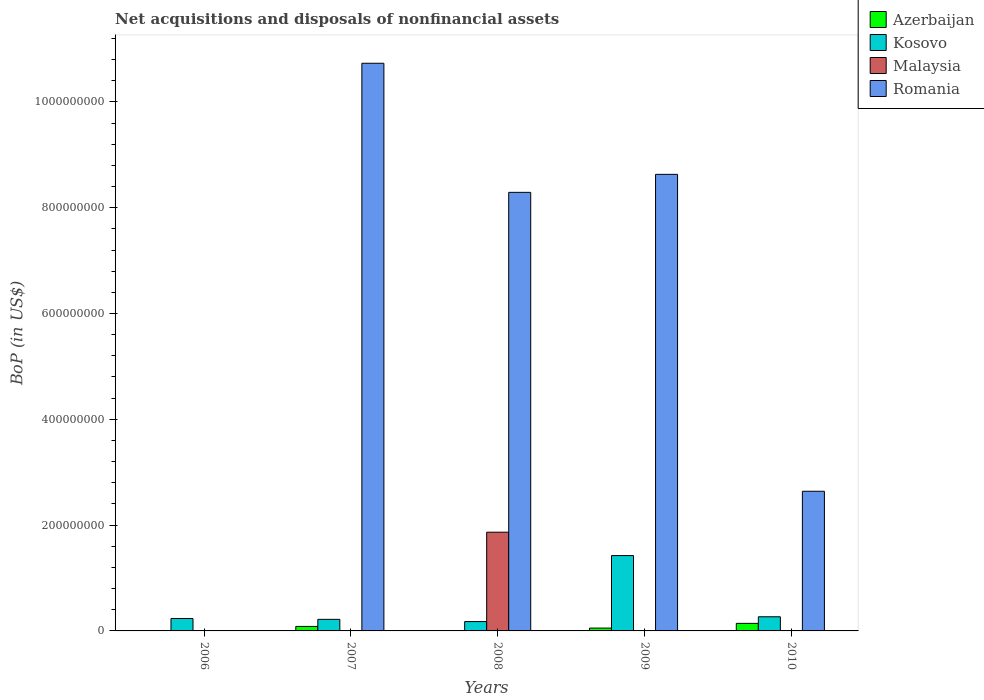How many groups of bars are there?
Your response must be concise. 5. Are the number of bars per tick equal to the number of legend labels?
Your answer should be compact. No. Are the number of bars on each tick of the X-axis equal?
Give a very brief answer. No. How many bars are there on the 2nd tick from the left?
Your response must be concise. 3. What is the Balance of Payments in Kosovo in 2006?
Ensure brevity in your answer.  2.35e+07. Across all years, what is the maximum Balance of Payments in Kosovo?
Provide a succinct answer. 1.42e+08. Across all years, what is the minimum Balance of Payments in Azerbaijan?
Ensure brevity in your answer.  0. What is the total Balance of Payments in Malaysia in the graph?
Offer a very short reply. 1.87e+08. What is the difference between the Balance of Payments in Azerbaijan in 2006 and that in 2009?
Provide a succinct answer. -5.06e+06. What is the difference between the Balance of Payments in Azerbaijan in 2008 and the Balance of Payments in Romania in 2009?
Your answer should be very brief. -8.63e+08. What is the average Balance of Payments in Romania per year?
Offer a very short reply. 6.06e+08. In the year 2006, what is the difference between the Balance of Payments in Kosovo and Balance of Payments in Azerbaijan?
Your response must be concise. 2.32e+07. What is the ratio of the Balance of Payments in Azerbaijan in 2007 to that in 2010?
Make the answer very short. 0.59. Is the Balance of Payments in Kosovo in 2007 less than that in 2010?
Your answer should be very brief. Yes. What is the difference between the highest and the second highest Balance of Payments in Kosovo?
Your answer should be compact. 1.16e+08. What is the difference between the highest and the lowest Balance of Payments in Malaysia?
Give a very brief answer. 1.87e+08. In how many years, is the Balance of Payments in Romania greater than the average Balance of Payments in Romania taken over all years?
Provide a succinct answer. 3. Is it the case that in every year, the sum of the Balance of Payments in Kosovo and Balance of Payments in Malaysia is greater than the Balance of Payments in Romania?
Your answer should be very brief. No. How many bars are there?
Your answer should be compact. 14. How many years are there in the graph?
Provide a short and direct response. 5. What is the difference between two consecutive major ticks on the Y-axis?
Offer a terse response. 2.00e+08. Does the graph contain any zero values?
Keep it short and to the point. Yes. Where does the legend appear in the graph?
Provide a succinct answer. Top right. How many legend labels are there?
Make the answer very short. 4. How are the legend labels stacked?
Give a very brief answer. Vertical. What is the title of the graph?
Make the answer very short. Net acquisitions and disposals of nonfinancial assets. What is the label or title of the Y-axis?
Offer a terse response. BoP (in US$). What is the BoP (in US$) in Azerbaijan in 2006?
Ensure brevity in your answer.  2.85e+05. What is the BoP (in US$) in Kosovo in 2006?
Provide a succinct answer. 2.35e+07. What is the BoP (in US$) in Romania in 2006?
Your response must be concise. 0. What is the BoP (in US$) in Azerbaijan in 2007?
Provide a short and direct response. 8.49e+06. What is the BoP (in US$) of Kosovo in 2007?
Offer a terse response. 2.19e+07. What is the BoP (in US$) of Malaysia in 2007?
Your answer should be very brief. 0. What is the BoP (in US$) of Romania in 2007?
Your response must be concise. 1.07e+09. What is the BoP (in US$) of Azerbaijan in 2008?
Ensure brevity in your answer.  0. What is the BoP (in US$) of Kosovo in 2008?
Your answer should be compact. 1.77e+07. What is the BoP (in US$) in Malaysia in 2008?
Keep it short and to the point. 1.87e+08. What is the BoP (in US$) of Romania in 2008?
Provide a short and direct response. 8.29e+08. What is the BoP (in US$) of Azerbaijan in 2009?
Offer a very short reply. 5.35e+06. What is the BoP (in US$) in Kosovo in 2009?
Provide a succinct answer. 1.42e+08. What is the BoP (in US$) in Malaysia in 2009?
Your response must be concise. 0. What is the BoP (in US$) in Romania in 2009?
Make the answer very short. 8.63e+08. What is the BoP (in US$) of Azerbaijan in 2010?
Give a very brief answer. 1.43e+07. What is the BoP (in US$) in Kosovo in 2010?
Give a very brief answer. 2.67e+07. What is the BoP (in US$) of Malaysia in 2010?
Provide a succinct answer. 0. What is the BoP (in US$) in Romania in 2010?
Offer a very short reply. 2.64e+08. Across all years, what is the maximum BoP (in US$) in Azerbaijan?
Your response must be concise. 1.43e+07. Across all years, what is the maximum BoP (in US$) of Kosovo?
Ensure brevity in your answer.  1.42e+08. Across all years, what is the maximum BoP (in US$) in Malaysia?
Your answer should be compact. 1.87e+08. Across all years, what is the maximum BoP (in US$) in Romania?
Make the answer very short. 1.07e+09. Across all years, what is the minimum BoP (in US$) in Azerbaijan?
Provide a short and direct response. 0. Across all years, what is the minimum BoP (in US$) of Kosovo?
Give a very brief answer. 1.77e+07. Across all years, what is the minimum BoP (in US$) in Malaysia?
Make the answer very short. 0. Across all years, what is the minimum BoP (in US$) of Romania?
Ensure brevity in your answer.  0. What is the total BoP (in US$) of Azerbaijan in the graph?
Your answer should be compact. 2.84e+07. What is the total BoP (in US$) of Kosovo in the graph?
Provide a short and direct response. 2.32e+08. What is the total BoP (in US$) of Malaysia in the graph?
Your answer should be compact. 1.87e+08. What is the total BoP (in US$) of Romania in the graph?
Make the answer very short. 3.03e+09. What is the difference between the BoP (in US$) in Azerbaijan in 2006 and that in 2007?
Provide a succinct answer. -8.21e+06. What is the difference between the BoP (in US$) in Kosovo in 2006 and that in 2007?
Give a very brief answer. 1.60e+06. What is the difference between the BoP (in US$) in Kosovo in 2006 and that in 2008?
Your answer should be compact. 5.78e+06. What is the difference between the BoP (in US$) of Azerbaijan in 2006 and that in 2009?
Provide a succinct answer. -5.06e+06. What is the difference between the BoP (in US$) in Kosovo in 2006 and that in 2009?
Make the answer very short. -1.19e+08. What is the difference between the BoP (in US$) of Azerbaijan in 2006 and that in 2010?
Offer a very short reply. -1.40e+07. What is the difference between the BoP (in US$) of Kosovo in 2006 and that in 2010?
Your answer should be compact. -3.27e+06. What is the difference between the BoP (in US$) in Kosovo in 2007 and that in 2008?
Give a very brief answer. 4.18e+06. What is the difference between the BoP (in US$) in Romania in 2007 and that in 2008?
Keep it short and to the point. 2.44e+08. What is the difference between the BoP (in US$) in Azerbaijan in 2007 and that in 2009?
Your answer should be very brief. 3.14e+06. What is the difference between the BoP (in US$) of Kosovo in 2007 and that in 2009?
Your response must be concise. -1.21e+08. What is the difference between the BoP (in US$) in Romania in 2007 and that in 2009?
Give a very brief answer. 2.10e+08. What is the difference between the BoP (in US$) in Azerbaijan in 2007 and that in 2010?
Ensure brevity in your answer.  -5.80e+06. What is the difference between the BoP (in US$) of Kosovo in 2007 and that in 2010?
Offer a terse response. -4.87e+06. What is the difference between the BoP (in US$) of Romania in 2007 and that in 2010?
Your response must be concise. 8.09e+08. What is the difference between the BoP (in US$) in Kosovo in 2008 and that in 2009?
Your response must be concise. -1.25e+08. What is the difference between the BoP (in US$) in Romania in 2008 and that in 2009?
Offer a very short reply. -3.40e+07. What is the difference between the BoP (in US$) in Kosovo in 2008 and that in 2010?
Offer a terse response. -9.06e+06. What is the difference between the BoP (in US$) of Romania in 2008 and that in 2010?
Give a very brief answer. 5.65e+08. What is the difference between the BoP (in US$) in Azerbaijan in 2009 and that in 2010?
Your response must be concise. -8.94e+06. What is the difference between the BoP (in US$) of Kosovo in 2009 and that in 2010?
Provide a short and direct response. 1.16e+08. What is the difference between the BoP (in US$) of Romania in 2009 and that in 2010?
Provide a short and direct response. 5.99e+08. What is the difference between the BoP (in US$) of Azerbaijan in 2006 and the BoP (in US$) of Kosovo in 2007?
Keep it short and to the point. -2.16e+07. What is the difference between the BoP (in US$) in Azerbaijan in 2006 and the BoP (in US$) in Romania in 2007?
Provide a succinct answer. -1.07e+09. What is the difference between the BoP (in US$) of Kosovo in 2006 and the BoP (in US$) of Romania in 2007?
Give a very brief answer. -1.05e+09. What is the difference between the BoP (in US$) in Azerbaijan in 2006 and the BoP (in US$) in Kosovo in 2008?
Your response must be concise. -1.74e+07. What is the difference between the BoP (in US$) of Azerbaijan in 2006 and the BoP (in US$) of Malaysia in 2008?
Provide a short and direct response. -1.86e+08. What is the difference between the BoP (in US$) in Azerbaijan in 2006 and the BoP (in US$) in Romania in 2008?
Keep it short and to the point. -8.29e+08. What is the difference between the BoP (in US$) of Kosovo in 2006 and the BoP (in US$) of Malaysia in 2008?
Provide a short and direct response. -1.63e+08. What is the difference between the BoP (in US$) in Kosovo in 2006 and the BoP (in US$) in Romania in 2008?
Your answer should be compact. -8.06e+08. What is the difference between the BoP (in US$) of Azerbaijan in 2006 and the BoP (in US$) of Kosovo in 2009?
Provide a succinct answer. -1.42e+08. What is the difference between the BoP (in US$) of Azerbaijan in 2006 and the BoP (in US$) of Romania in 2009?
Ensure brevity in your answer.  -8.63e+08. What is the difference between the BoP (in US$) in Kosovo in 2006 and the BoP (in US$) in Romania in 2009?
Provide a short and direct response. -8.40e+08. What is the difference between the BoP (in US$) of Azerbaijan in 2006 and the BoP (in US$) of Kosovo in 2010?
Offer a terse response. -2.64e+07. What is the difference between the BoP (in US$) of Azerbaijan in 2006 and the BoP (in US$) of Romania in 2010?
Provide a succinct answer. -2.64e+08. What is the difference between the BoP (in US$) of Kosovo in 2006 and the BoP (in US$) of Romania in 2010?
Ensure brevity in your answer.  -2.41e+08. What is the difference between the BoP (in US$) of Azerbaijan in 2007 and the BoP (in US$) of Kosovo in 2008?
Ensure brevity in your answer.  -9.18e+06. What is the difference between the BoP (in US$) of Azerbaijan in 2007 and the BoP (in US$) of Malaysia in 2008?
Ensure brevity in your answer.  -1.78e+08. What is the difference between the BoP (in US$) in Azerbaijan in 2007 and the BoP (in US$) in Romania in 2008?
Your answer should be compact. -8.21e+08. What is the difference between the BoP (in US$) of Kosovo in 2007 and the BoP (in US$) of Malaysia in 2008?
Provide a short and direct response. -1.65e+08. What is the difference between the BoP (in US$) in Kosovo in 2007 and the BoP (in US$) in Romania in 2008?
Ensure brevity in your answer.  -8.07e+08. What is the difference between the BoP (in US$) in Azerbaijan in 2007 and the BoP (in US$) in Kosovo in 2009?
Provide a short and direct response. -1.34e+08. What is the difference between the BoP (in US$) of Azerbaijan in 2007 and the BoP (in US$) of Romania in 2009?
Offer a very short reply. -8.55e+08. What is the difference between the BoP (in US$) in Kosovo in 2007 and the BoP (in US$) in Romania in 2009?
Make the answer very short. -8.41e+08. What is the difference between the BoP (in US$) in Azerbaijan in 2007 and the BoP (in US$) in Kosovo in 2010?
Give a very brief answer. -1.82e+07. What is the difference between the BoP (in US$) in Azerbaijan in 2007 and the BoP (in US$) in Romania in 2010?
Your response must be concise. -2.56e+08. What is the difference between the BoP (in US$) in Kosovo in 2007 and the BoP (in US$) in Romania in 2010?
Provide a short and direct response. -2.42e+08. What is the difference between the BoP (in US$) in Kosovo in 2008 and the BoP (in US$) in Romania in 2009?
Provide a short and direct response. -8.45e+08. What is the difference between the BoP (in US$) in Malaysia in 2008 and the BoP (in US$) in Romania in 2009?
Offer a very short reply. -6.76e+08. What is the difference between the BoP (in US$) in Kosovo in 2008 and the BoP (in US$) in Romania in 2010?
Provide a short and direct response. -2.46e+08. What is the difference between the BoP (in US$) in Malaysia in 2008 and the BoP (in US$) in Romania in 2010?
Keep it short and to the point. -7.74e+07. What is the difference between the BoP (in US$) in Azerbaijan in 2009 and the BoP (in US$) in Kosovo in 2010?
Make the answer very short. -2.14e+07. What is the difference between the BoP (in US$) in Azerbaijan in 2009 and the BoP (in US$) in Romania in 2010?
Give a very brief answer. -2.59e+08. What is the difference between the BoP (in US$) in Kosovo in 2009 and the BoP (in US$) in Romania in 2010?
Keep it short and to the point. -1.22e+08. What is the average BoP (in US$) of Azerbaijan per year?
Provide a succinct answer. 5.68e+06. What is the average BoP (in US$) in Kosovo per year?
Make the answer very short. 4.64e+07. What is the average BoP (in US$) of Malaysia per year?
Keep it short and to the point. 3.73e+07. What is the average BoP (in US$) of Romania per year?
Provide a succinct answer. 6.06e+08. In the year 2006, what is the difference between the BoP (in US$) of Azerbaijan and BoP (in US$) of Kosovo?
Provide a succinct answer. -2.32e+07. In the year 2007, what is the difference between the BoP (in US$) in Azerbaijan and BoP (in US$) in Kosovo?
Offer a terse response. -1.34e+07. In the year 2007, what is the difference between the BoP (in US$) in Azerbaijan and BoP (in US$) in Romania?
Offer a very short reply. -1.06e+09. In the year 2007, what is the difference between the BoP (in US$) in Kosovo and BoP (in US$) in Romania?
Your response must be concise. -1.05e+09. In the year 2008, what is the difference between the BoP (in US$) of Kosovo and BoP (in US$) of Malaysia?
Make the answer very short. -1.69e+08. In the year 2008, what is the difference between the BoP (in US$) of Kosovo and BoP (in US$) of Romania?
Provide a short and direct response. -8.11e+08. In the year 2008, what is the difference between the BoP (in US$) in Malaysia and BoP (in US$) in Romania?
Your answer should be very brief. -6.42e+08. In the year 2009, what is the difference between the BoP (in US$) in Azerbaijan and BoP (in US$) in Kosovo?
Your answer should be compact. -1.37e+08. In the year 2009, what is the difference between the BoP (in US$) of Azerbaijan and BoP (in US$) of Romania?
Your answer should be very brief. -8.58e+08. In the year 2009, what is the difference between the BoP (in US$) in Kosovo and BoP (in US$) in Romania?
Make the answer very short. -7.21e+08. In the year 2010, what is the difference between the BoP (in US$) in Azerbaijan and BoP (in US$) in Kosovo?
Ensure brevity in your answer.  -1.24e+07. In the year 2010, what is the difference between the BoP (in US$) of Azerbaijan and BoP (in US$) of Romania?
Keep it short and to the point. -2.50e+08. In the year 2010, what is the difference between the BoP (in US$) in Kosovo and BoP (in US$) in Romania?
Make the answer very short. -2.37e+08. What is the ratio of the BoP (in US$) in Azerbaijan in 2006 to that in 2007?
Make the answer very short. 0.03. What is the ratio of the BoP (in US$) of Kosovo in 2006 to that in 2007?
Your response must be concise. 1.07. What is the ratio of the BoP (in US$) of Kosovo in 2006 to that in 2008?
Keep it short and to the point. 1.33. What is the ratio of the BoP (in US$) of Azerbaijan in 2006 to that in 2009?
Make the answer very short. 0.05. What is the ratio of the BoP (in US$) in Kosovo in 2006 to that in 2009?
Make the answer very short. 0.16. What is the ratio of the BoP (in US$) of Azerbaijan in 2006 to that in 2010?
Your answer should be very brief. 0.02. What is the ratio of the BoP (in US$) of Kosovo in 2006 to that in 2010?
Offer a very short reply. 0.88. What is the ratio of the BoP (in US$) in Kosovo in 2007 to that in 2008?
Make the answer very short. 1.24. What is the ratio of the BoP (in US$) of Romania in 2007 to that in 2008?
Keep it short and to the point. 1.29. What is the ratio of the BoP (in US$) in Azerbaijan in 2007 to that in 2009?
Give a very brief answer. 1.59. What is the ratio of the BoP (in US$) in Kosovo in 2007 to that in 2009?
Offer a terse response. 0.15. What is the ratio of the BoP (in US$) of Romania in 2007 to that in 2009?
Ensure brevity in your answer.  1.24. What is the ratio of the BoP (in US$) of Azerbaijan in 2007 to that in 2010?
Your answer should be compact. 0.59. What is the ratio of the BoP (in US$) in Kosovo in 2007 to that in 2010?
Your answer should be compact. 0.82. What is the ratio of the BoP (in US$) in Romania in 2007 to that in 2010?
Your response must be concise. 4.06. What is the ratio of the BoP (in US$) in Kosovo in 2008 to that in 2009?
Your answer should be very brief. 0.12. What is the ratio of the BoP (in US$) of Romania in 2008 to that in 2009?
Keep it short and to the point. 0.96. What is the ratio of the BoP (in US$) in Kosovo in 2008 to that in 2010?
Offer a very short reply. 0.66. What is the ratio of the BoP (in US$) in Romania in 2008 to that in 2010?
Offer a terse response. 3.14. What is the ratio of the BoP (in US$) of Azerbaijan in 2009 to that in 2010?
Give a very brief answer. 0.37. What is the ratio of the BoP (in US$) in Kosovo in 2009 to that in 2010?
Your answer should be compact. 5.33. What is the ratio of the BoP (in US$) of Romania in 2009 to that in 2010?
Your answer should be compact. 3.27. What is the difference between the highest and the second highest BoP (in US$) in Azerbaijan?
Your response must be concise. 5.80e+06. What is the difference between the highest and the second highest BoP (in US$) of Kosovo?
Give a very brief answer. 1.16e+08. What is the difference between the highest and the second highest BoP (in US$) of Romania?
Your answer should be very brief. 2.10e+08. What is the difference between the highest and the lowest BoP (in US$) of Azerbaijan?
Keep it short and to the point. 1.43e+07. What is the difference between the highest and the lowest BoP (in US$) in Kosovo?
Provide a short and direct response. 1.25e+08. What is the difference between the highest and the lowest BoP (in US$) in Malaysia?
Keep it short and to the point. 1.87e+08. What is the difference between the highest and the lowest BoP (in US$) in Romania?
Your response must be concise. 1.07e+09. 